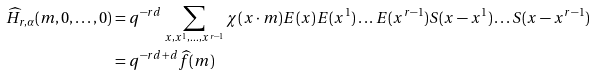<formula> <loc_0><loc_0><loc_500><loc_500>\widehat { H } _ { r , \alpha } ( m , 0 , \dots , 0 ) & = q ^ { - r d } \sum _ { x , x ^ { 1 } , \dots , x ^ { r - 1 } } \chi ( x \cdot m ) E ( x ) E ( x ^ { 1 } ) \dots E ( x ^ { r - 1 } ) S ( x - x ^ { 1 } ) \dots S ( x - x ^ { r - 1 } ) \\ & = q ^ { - r d + d } \widehat { f } ( m )</formula> 